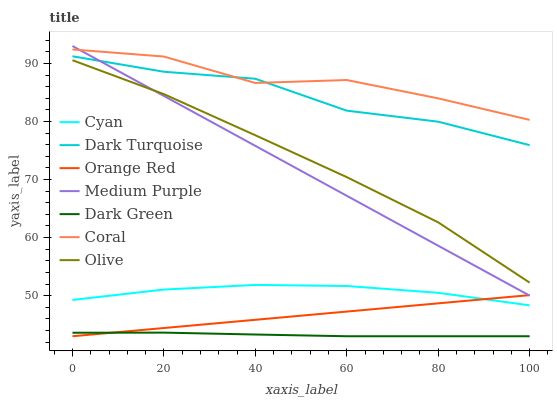Does Dark Green have the minimum area under the curve?
Answer yes or no. Yes. Does Coral have the maximum area under the curve?
Answer yes or no. Yes. Does Medium Purple have the minimum area under the curve?
Answer yes or no. No. Does Medium Purple have the maximum area under the curve?
Answer yes or no. No. Is Orange Red the smoothest?
Answer yes or no. Yes. Is Coral the roughest?
Answer yes or no. Yes. Is Medium Purple the smoothest?
Answer yes or no. No. Is Medium Purple the roughest?
Answer yes or no. No. Does Orange Red have the lowest value?
Answer yes or no. Yes. Does Medium Purple have the lowest value?
Answer yes or no. No. Does Medium Purple have the highest value?
Answer yes or no. Yes. Does Coral have the highest value?
Answer yes or no. No. Is Dark Green less than Medium Purple?
Answer yes or no. Yes. Is Dark Turquoise greater than Olive?
Answer yes or no. Yes. Does Coral intersect Dark Turquoise?
Answer yes or no. Yes. Is Coral less than Dark Turquoise?
Answer yes or no. No. Is Coral greater than Dark Turquoise?
Answer yes or no. No. Does Dark Green intersect Medium Purple?
Answer yes or no. No. 